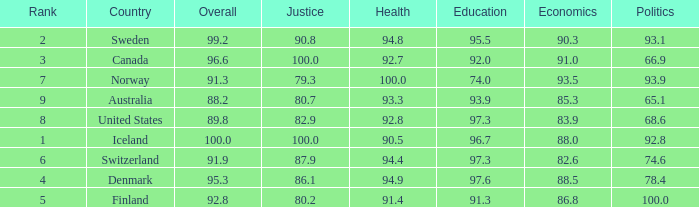What's the rank for iceland 1.0. 